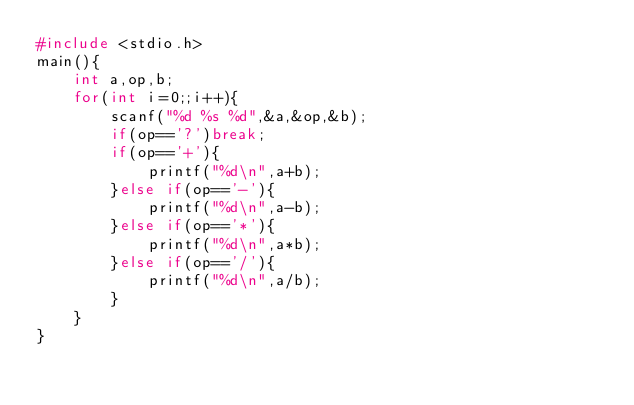Convert code to text. <code><loc_0><loc_0><loc_500><loc_500><_C_>#include <stdio.h>
main(){
    int a,op,b;
    for(int i=0;;i++){
        scanf("%d %s %d",&a,&op,&b);
        if(op=='?')break;
        if(op=='+'){
            printf("%d\n",a+b);
        }else if(op=='-'){
            printf("%d\n",a-b);
        }else if(op=='*'){
            printf("%d\n",a*b);
        }else if(op=='/'){
            printf("%d\n",a/b);
        }
    }
}
</code> 